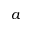Convert formula to latex. <formula><loc_0><loc_0><loc_500><loc_500>a</formula> 